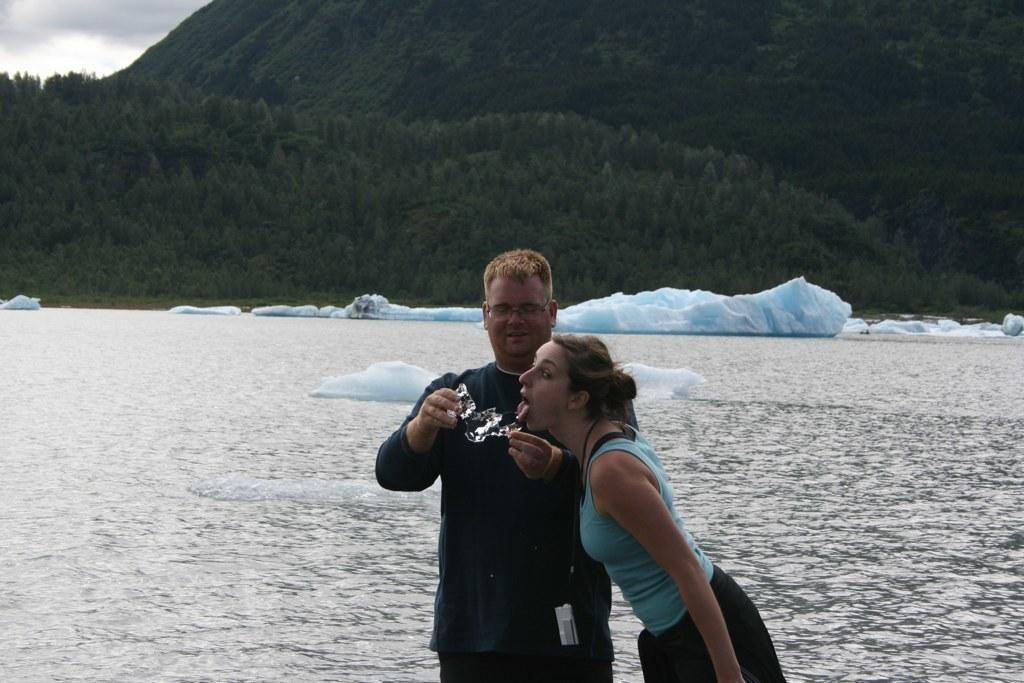How many people are in the foreground of the image? There are two people in the foreground of the image. What can be seen in the background of the image? There are trees and sky visible in the background of the image. What is the main subject in the center of the image? There is water with icebergs in the center of the image. How many women are present in the cemetery in the image? There is no cemetery present in the image, and therefore no women can be observed in a cemetery. 